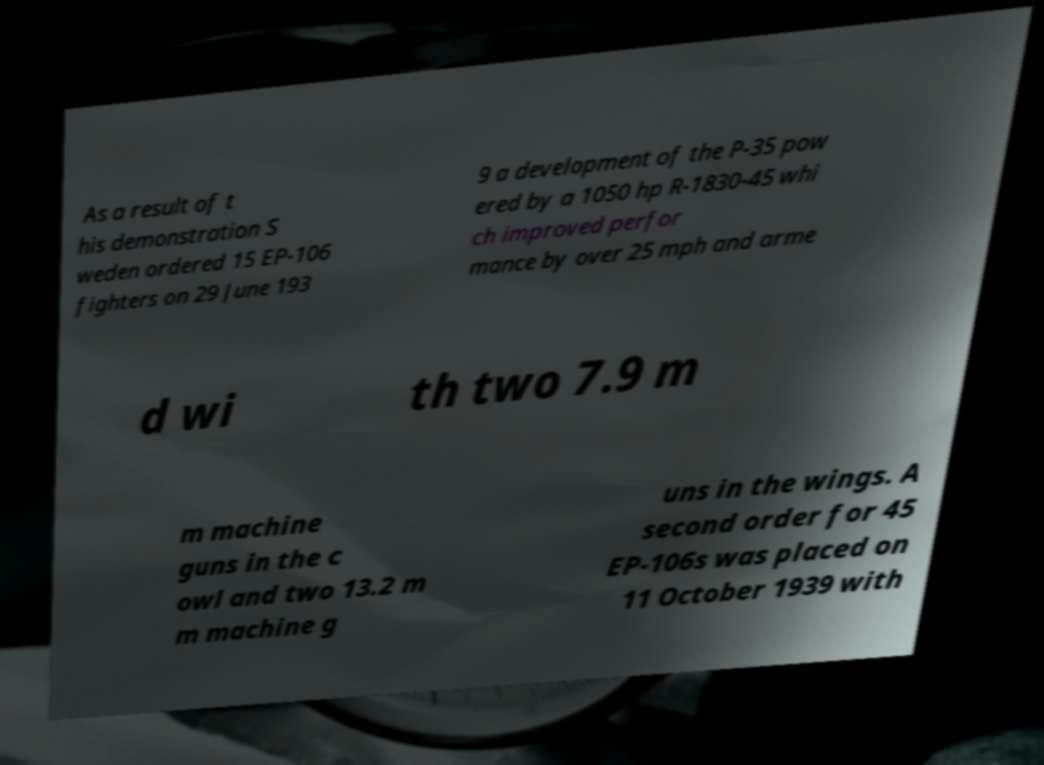For documentation purposes, I need the text within this image transcribed. Could you provide that? As a result of t his demonstration S weden ordered 15 EP-106 fighters on 29 June 193 9 a development of the P-35 pow ered by a 1050 hp R-1830-45 whi ch improved perfor mance by over 25 mph and arme d wi th two 7.9 m m machine guns in the c owl and two 13.2 m m machine g uns in the wings. A second order for 45 EP-106s was placed on 11 October 1939 with 